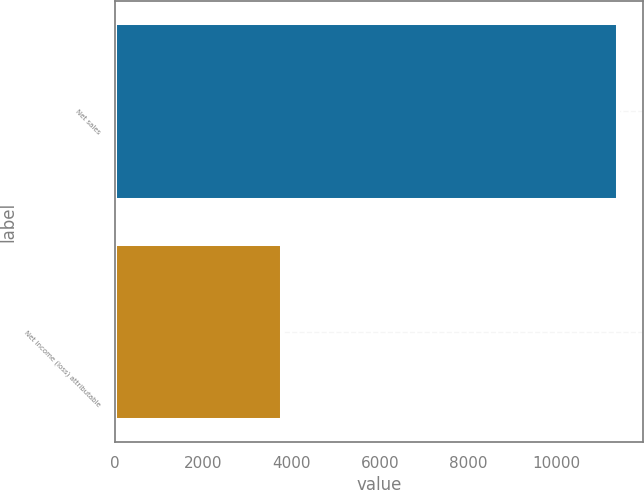Convert chart. <chart><loc_0><loc_0><loc_500><loc_500><bar_chart><fcel>Net sales<fcel>Net income (loss) attributable<nl><fcel>11393<fcel>3790<nl></chart> 